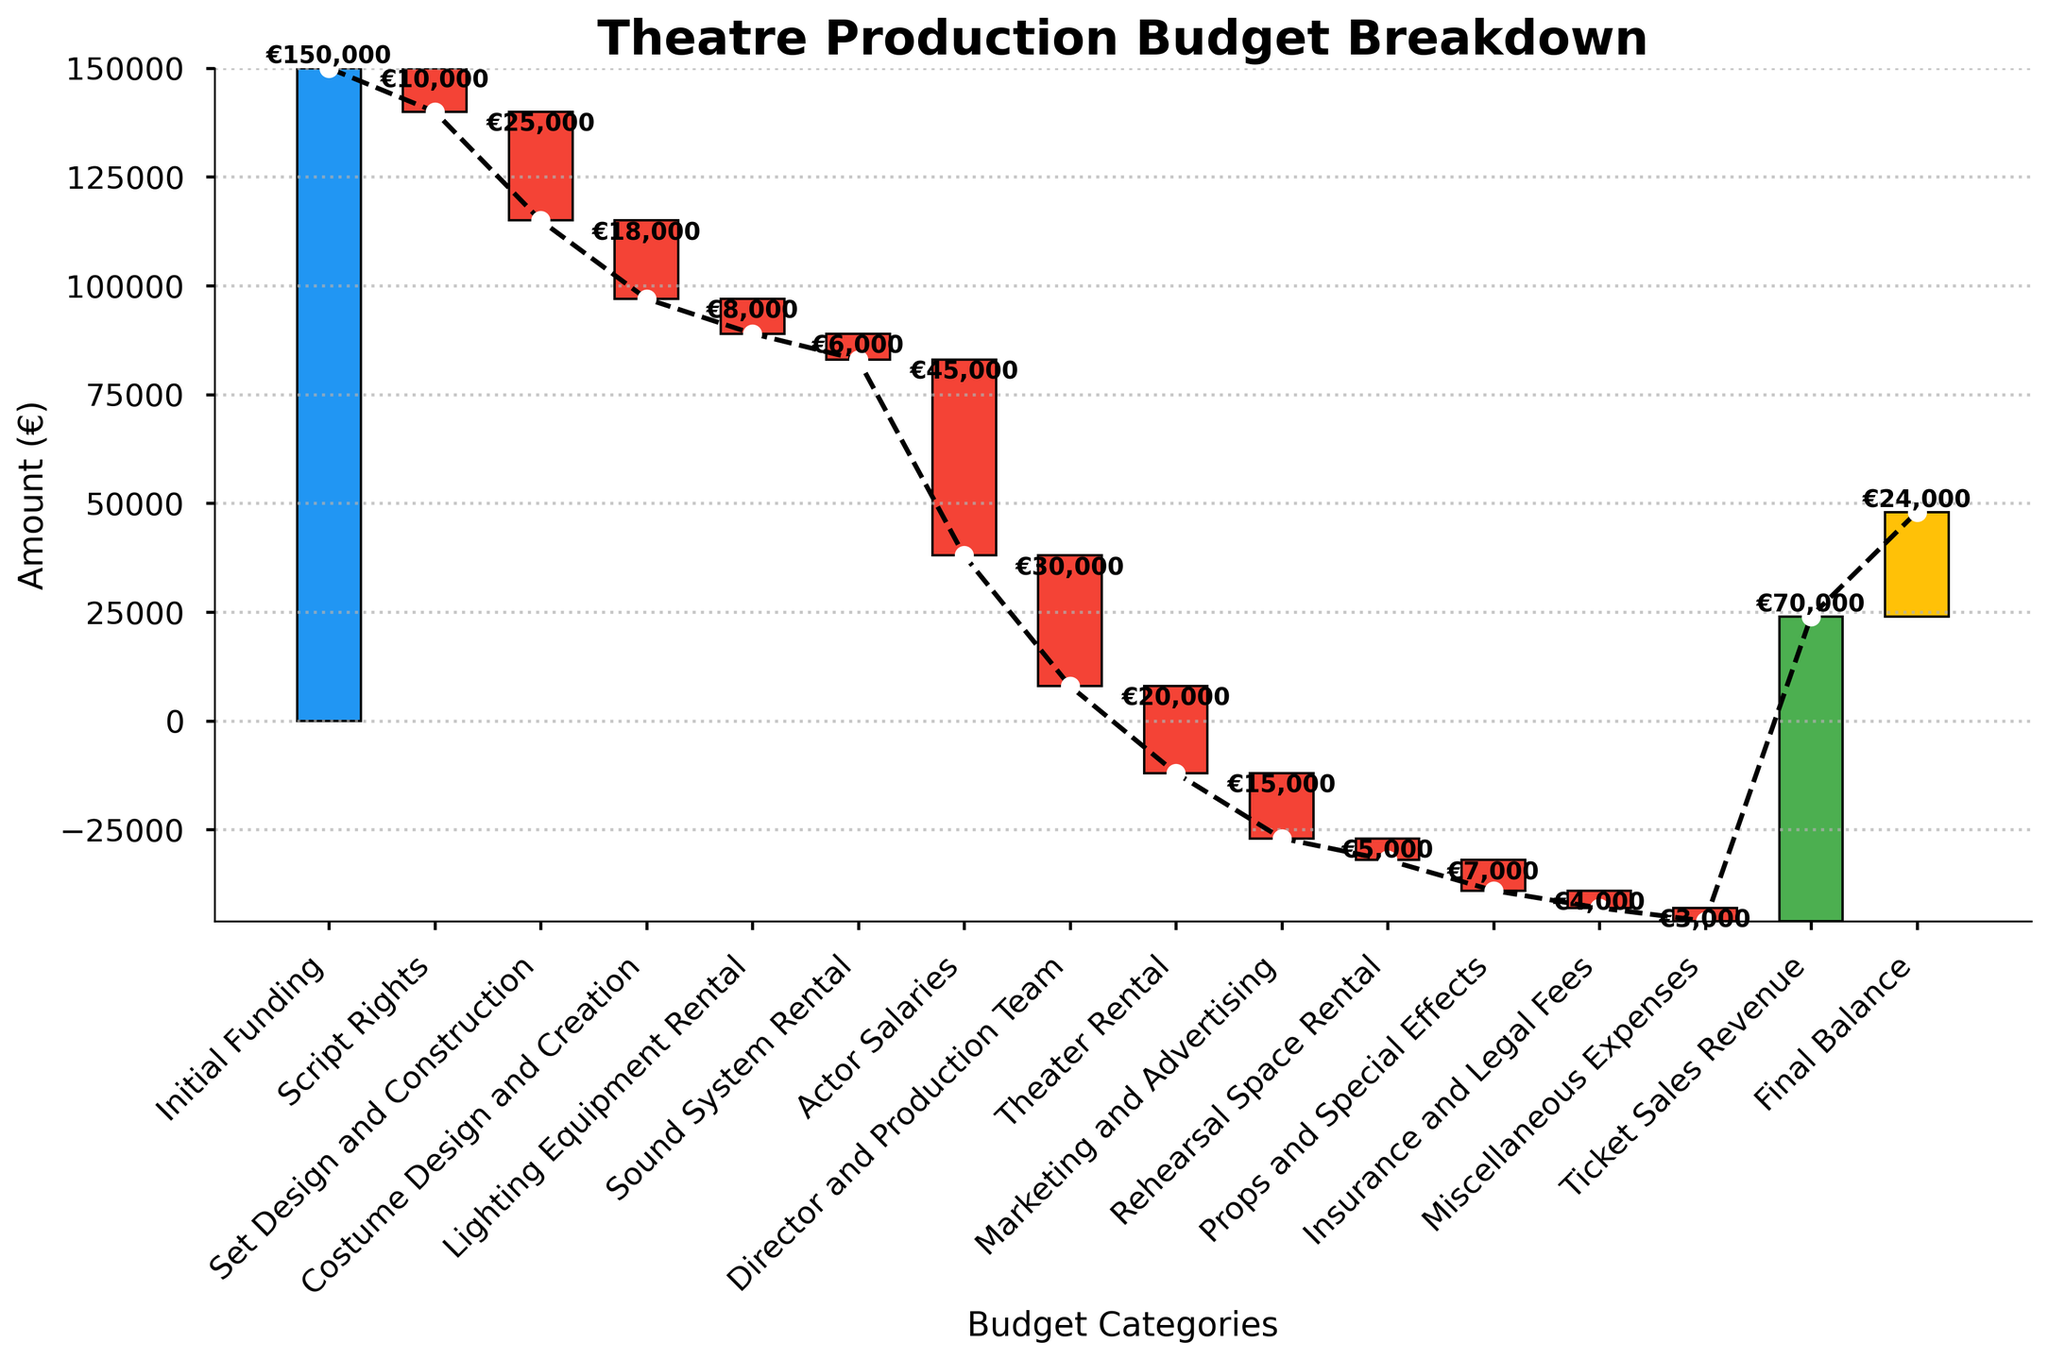What is the title of the chart? The title of the chart is presented at the top of the figure and is designed to easily convey the main subject.
Answer: Theatre Production Budget Breakdown What does the initial funding amount to? The initial funding amount is illustrated as the first bar in blue on the chart, and the value is directly labeled on the bar.
Answer: €150,000 How much was spent on Actor Salaries? Actor Salaries are represented in the chart, and the amount is labeled on the corresponding bar.
Answer: €45,000 What is the final balance after accounting for all expenses and revenues? The final balance is shown as the last bar in yellow on the chart, and the exact value is directly written on the bar.
Answer: €24,000 What is the cumulative amount spent on Script Rights, Set Design and Construction, and Costume Design and Creation? To find the cumulative amount, add the values of Script Rights (€10,000), Set Design and Construction (€25,000), and Costume Design and Creation (€18,000).
Answer: €53,000 Which category incurred the highest expense and what was the amount? By comparing the length of the red bars (expenses), the Actor Salaries bar is the longest, indicating the highest expense. The amount is labeled on the bar.
Answer: Actor Salaries, €45,000 What is the total revenue from Ticket Sales? The total revenue from Ticket Sales is indicated by a green upward bar in the latter part of the chart, with the amount labeled on it.
Answer: €70,000 How much was the expense for Marketing and Advertising compared to Theater Rental? To compare, note the values for Marketing and Advertising (€15,000) and Theater Rental (€20,000). Theatre Rental has a higher value, and the difference is €5,000.
Answer: €5,000 more for Theater Rental What are the colors used to represent funding, expenses, revenues, and final balance? By looking at the chart, Initial Funding is in blue, expenses in red, revenues in green, and the final balance in yellow.
Answer: Blue, Red, Green, Yellow How much is the total expense incurred excluding revenues and initial funding? Total Expense can be computed by summing up all negative amounts: €10,000 + €25,000 + €18,000 + €8,000 + €6,000 + €45,000 + €30,000 + €20,000 + €15,000 + €5,000 + €7,000 + €4,000 + €3,000.
Answer: €196,000 